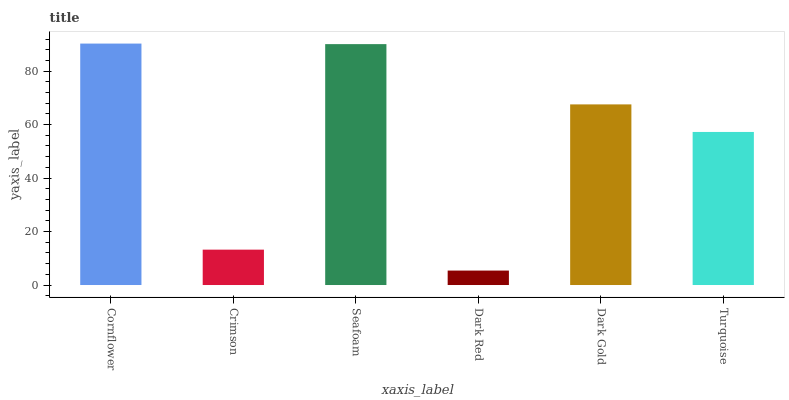Is Dark Red the minimum?
Answer yes or no. Yes. Is Cornflower the maximum?
Answer yes or no. Yes. Is Crimson the minimum?
Answer yes or no. No. Is Crimson the maximum?
Answer yes or no. No. Is Cornflower greater than Crimson?
Answer yes or no. Yes. Is Crimson less than Cornflower?
Answer yes or no. Yes. Is Crimson greater than Cornflower?
Answer yes or no. No. Is Cornflower less than Crimson?
Answer yes or no. No. Is Dark Gold the high median?
Answer yes or no. Yes. Is Turquoise the low median?
Answer yes or no. Yes. Is Crimson the high median?
Answer yes or no. No. Is Cornflower the low median?
Answer yes or no. No. 